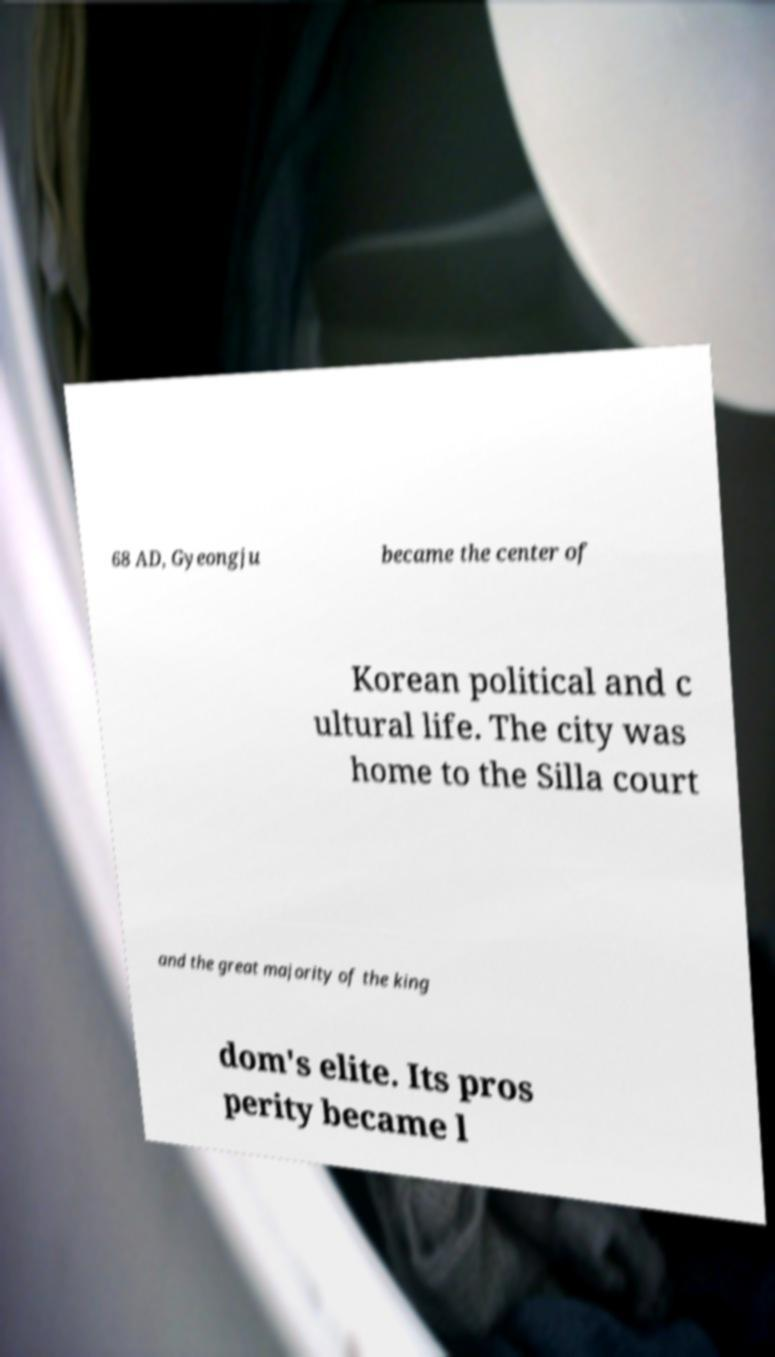What messages or text are displayed in this image? I need them in a readable, typed format. 68 AD, Gyeongju became the center of Korean political and c ultural life. The city was home to the Silla court and the great majority of the king dom's elite. Its pros perity became l 